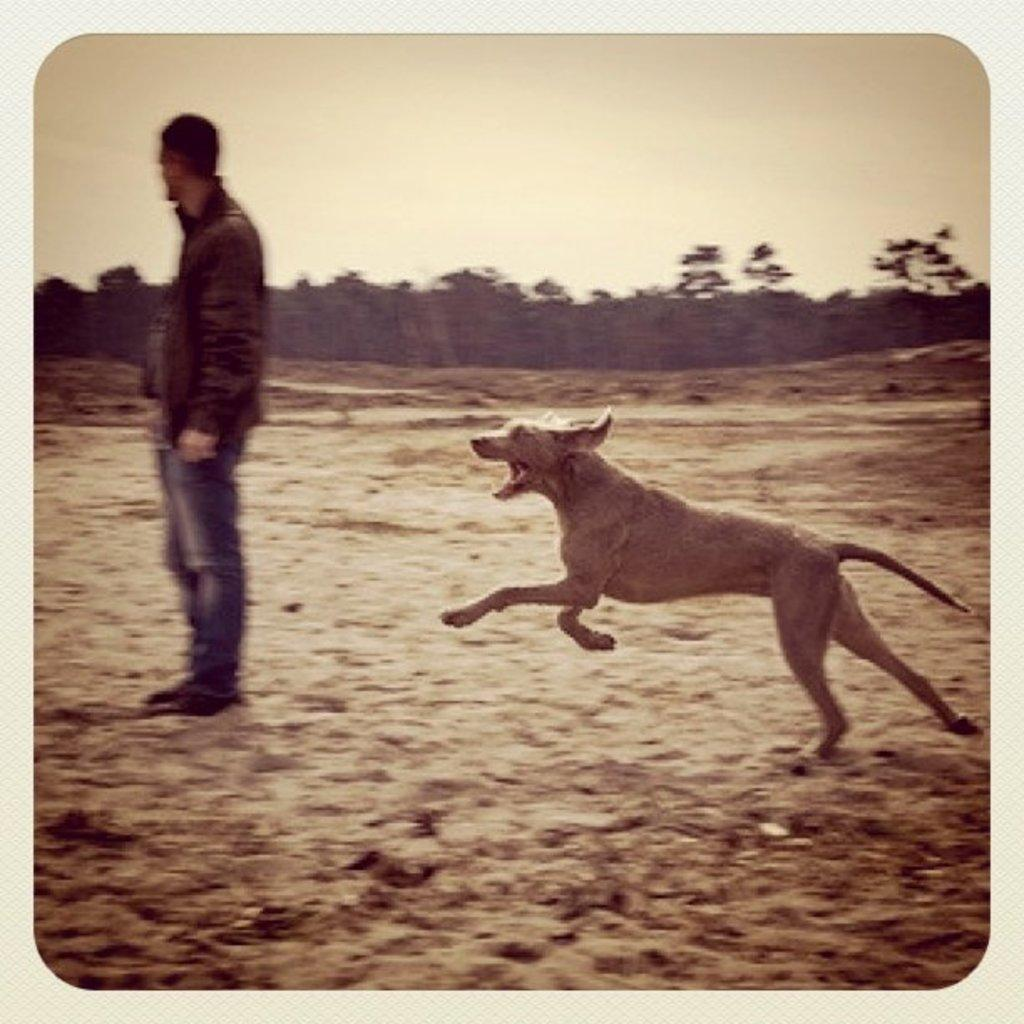Who is present in the image? There is a man in the image. What other living creature can be seen in the image? There is a dog in the image. What can be seen in the background of the image? There are trees in the background of the image. What type of bun is the man holding in the image? There is no bun present in the image; the man is not holding any baked goods. 